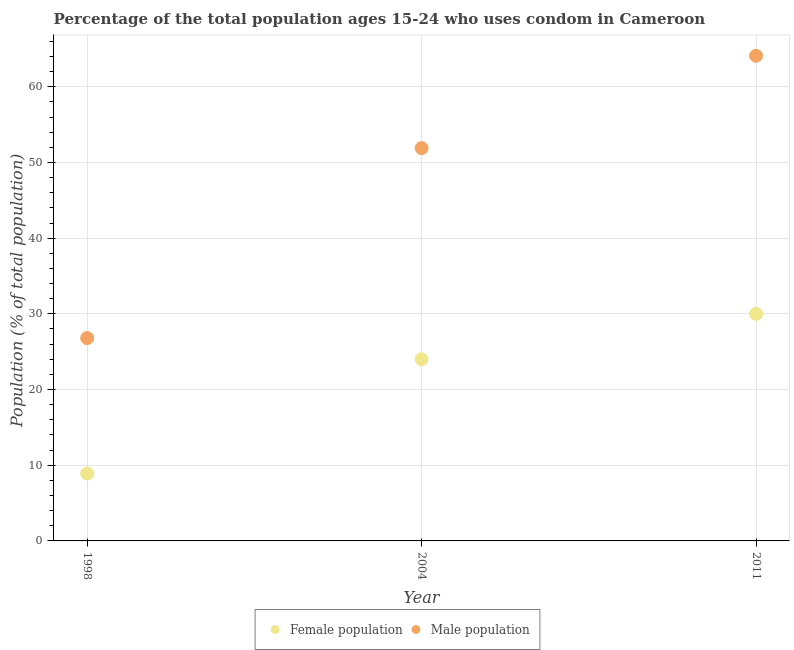What is the male population in 1998?
Your answer should be very brief. 26.8. Across all years, what is the maximum male population?
Make the answer very short. 64.1. Across all years, what is the minimum male population?
Make the answer very short. 26.8. In which year was the female population maximum?
Your answer should be very brief. 2011. What is the total male population in the graph?
Your response must be concise. 142.8. What is the difference between the male population in 1998 and that in 2004?
Make the answer very short. -25.1. What is the difference between the female population in 2011 and the male population in 1998?
Your answer should be compact. 3.2. What is the average male population per year?
Offer a very short reply. 47.6. In the year 2004, what is the difference between the male population and female population?
Provide a succinct answer. 27.9. In how many years, is the female population greater than 60 %?
Provide a short and direct response. 0. What is the ratio of the male population in 1998 to that in 2011?
Give a very brief answer. 0.42. Is the female population in 1998 less than that in 2011?
Make the answer very short. Yes. What is the difference between the highest and the second highest male population?
Offer a very short reply. 12.2. What is the difference between the highest and the lowest male population?
Provide a succinct answer. 37.3. Does the male population monotonically increase over the years?
Your response must be concise. Yes. Is the female population strictly greater than the male population over the years?
Ensure brevity in your answer.  No. Is the male population strictly less than the female population over the years?
Ensure brevity in your answer.  No. How many dotlines are there?
Provide a short and direct response. 2. How many years are there in the graph?
Ensure brevity in your answer.  3. What is the difference between two consecutive major ticks on the Y-axis?
Make the answer very short. 10. How are the legend labels stacked?
Your response must be concise. Horizontal. What is the title of the graph?
Provide a succinct answer. Percentage of the total population ages 15-24 who uses condom in Cameroon. What is the label or title of the Y-axis?
Keep it short and to the point. Population (% of total population) . What is the Population (% of total population)  of Male population in 1998?
Offer a very short reply. 26.8. What is the Population (% of total population)  of Male population in 2004?
Your answer should be compact. 51.9. What is the Population (% of total population)  of Male population in 2011?
Provide a succinct answer. 64.1. Across all years, what is the maximum Population (% of total population)  of Female population?
Your response must be concise. 30. Across all years, what is the maximum Population (% of total population)  in Male population?
Make the answer very short. 64.1. Across all years, what is the minimum Population (% of total population)  in Female population?
Keep it short and to the point. 8.9. Across all years, what is the minimum Population (% of total population)  in Male population?
Ensure brevity in your answer.  26.8. What is the total Population (% of total population)  in Female population in the graph?
Keep it short and to the point. 62.9. What is the total Population (% of total population)  in Male population in the graph?
Give a very brief answer. 142.8. What is the difference between the Population (% of total population)  in Female population in 1998 and that in 2004?
Offer a very short reply. -15.1. What is the difference between the Population (% of total population)  of Male population in 1998 and that in 2004?
Your answer should be compact. -25.1. What is the difference between the Population (% of total population)  of Female population in 1998 and that in 2011?
Your answer should be compact. -21.1. What is the difference between the Population (% of total population)  of Male population in 1998 and that in 2011?
Offer a very short reply. -37.3. What is the difference between the Population (% of total population)  in Female population in 1998 and the Population (% of total population)  in Male population in 2004?
Make the answer very short. -43. What is the difference between the Population (% of total population)  in Female population in 1998 and the Population (% of total population)  in Male population in 2011?
Your response must be concise. -55.2. What is the difference between the Population (% of total population)  of Female population in 2004 and the Population (% of total population)  of Male population in 2011?
Provide a succinct answer. -40.1. What is the average Population (% of total population)  of Female population per year?
Provide a succinct answer. 20.97. What is the average Population (% of total population)  of Male population per year?
Give a very brief answer. 47.6. In the year 1998, what is the difference between the Population (% of total population)  of Female population and Population (% of total population)  of Male population?
Keep it short and to the point. -17.9. In the year 2004, what is the difference between the Population (% of total population)  of Female population and Population (% of total population)  of Male population?
Offer a terse response. -27.9. In the year 2011, what is the difference between the Population (% of total population)  of Female population and Population (% of total population)  of Male population?
Provide a succinct answer. -34.1. What is the ratio of the Population (% of total population)  in Female population in 1998 to that in 2004?
Offer a very short reply. 0.37. What is the ratio of the Population (% of total population)  of Male population in 1998 to that in 2004?
Offer a terse response. 0.52. What is the ratio of the Population (% of total population)  of Female population in 1998 to that in 2011?
Your answer should be compact. 0.3. What is the ratio of the Population (% of total population)  of Male population in 1998 to that in 2011?
Make the answer very short. 0.42. What is the ratio of the Population (% of total population)  of Male population in 2004 to that in 2011?
Ensure brevity in your answer.  0.81. What is the difference between the highest and the second highest Population (% of total population)  of Male population?
Ensure brevity in your answer.  12.2. What is the difference between the highest and the lowest Population (% of total population)  of Female population?
Your response must be concise. 21.1. What is the difference between the highest and the lowest Population (% of total population)  of Male population?
Provide a short and direct response. 37.3. 